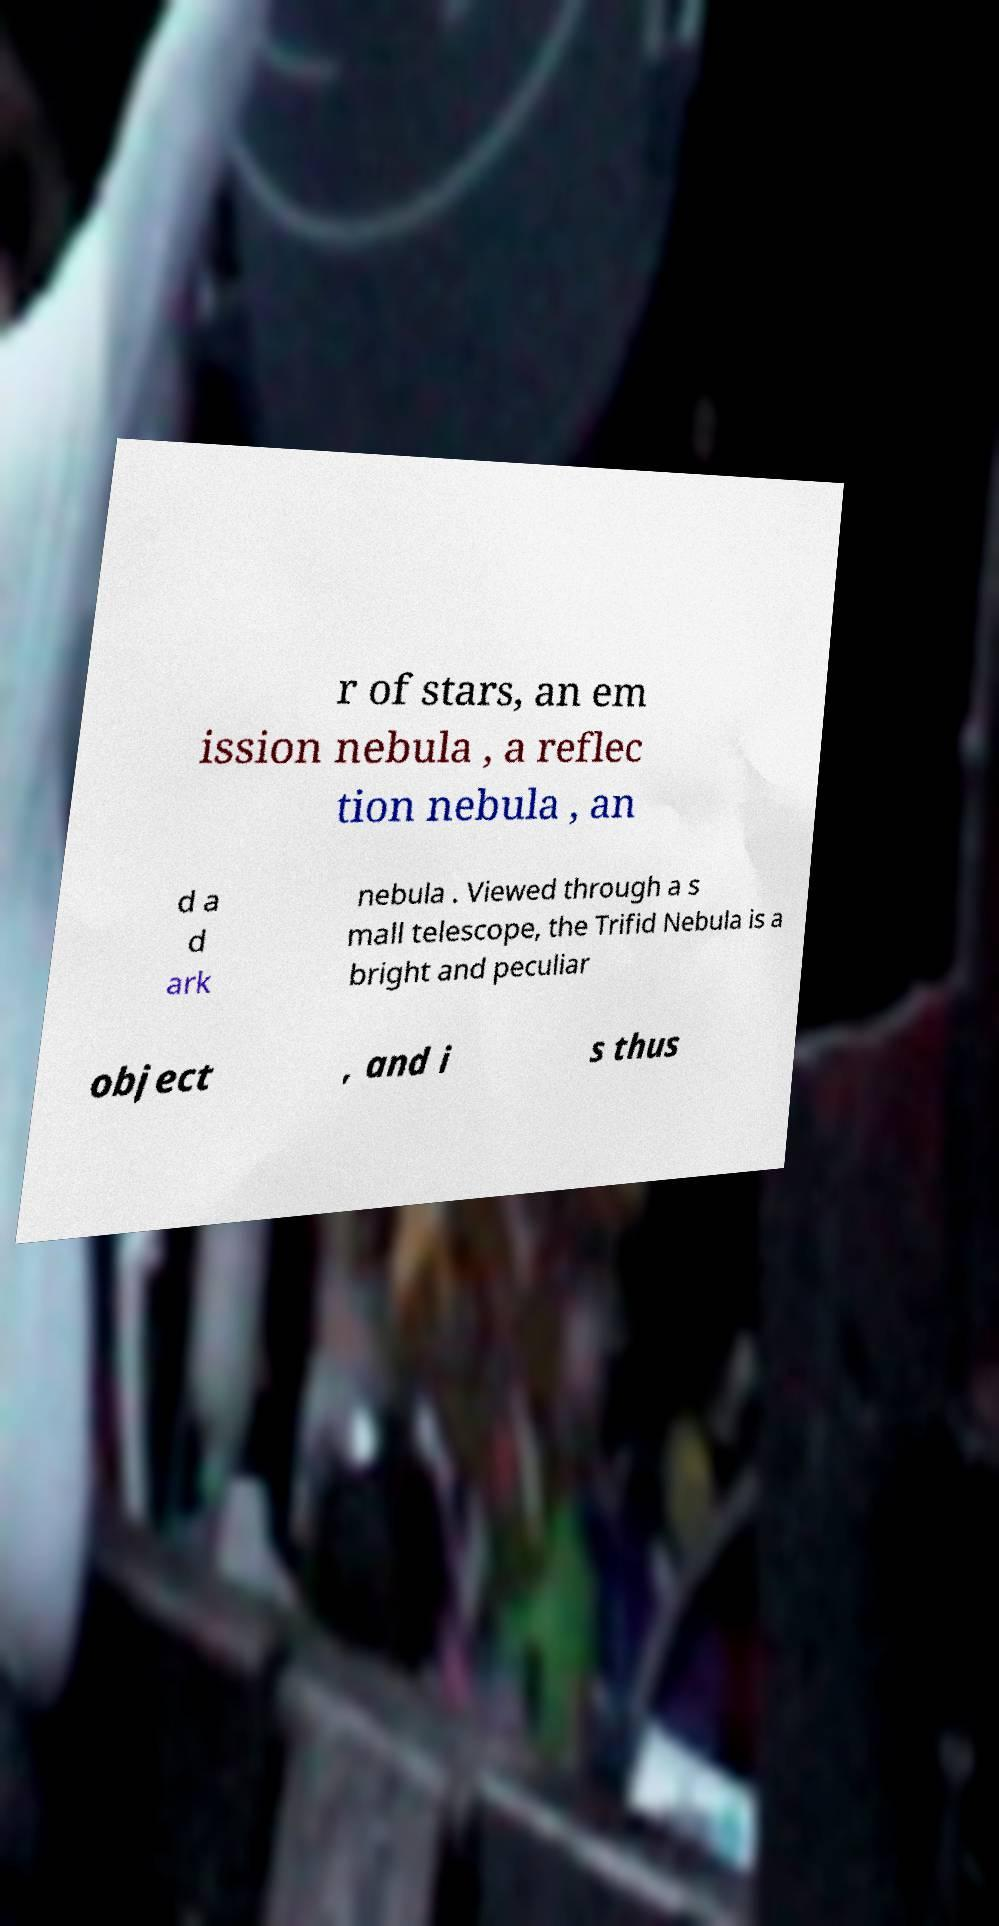For documentation purposes, I need the text within this image transcribed. Could you provide that? r of stars, an em ission nebula , a reflec tion nebula , an d a d ark nebula . Viewed through a s mall telescope, the Trifid Nebula is a bright and peculiar object , and i s thus 